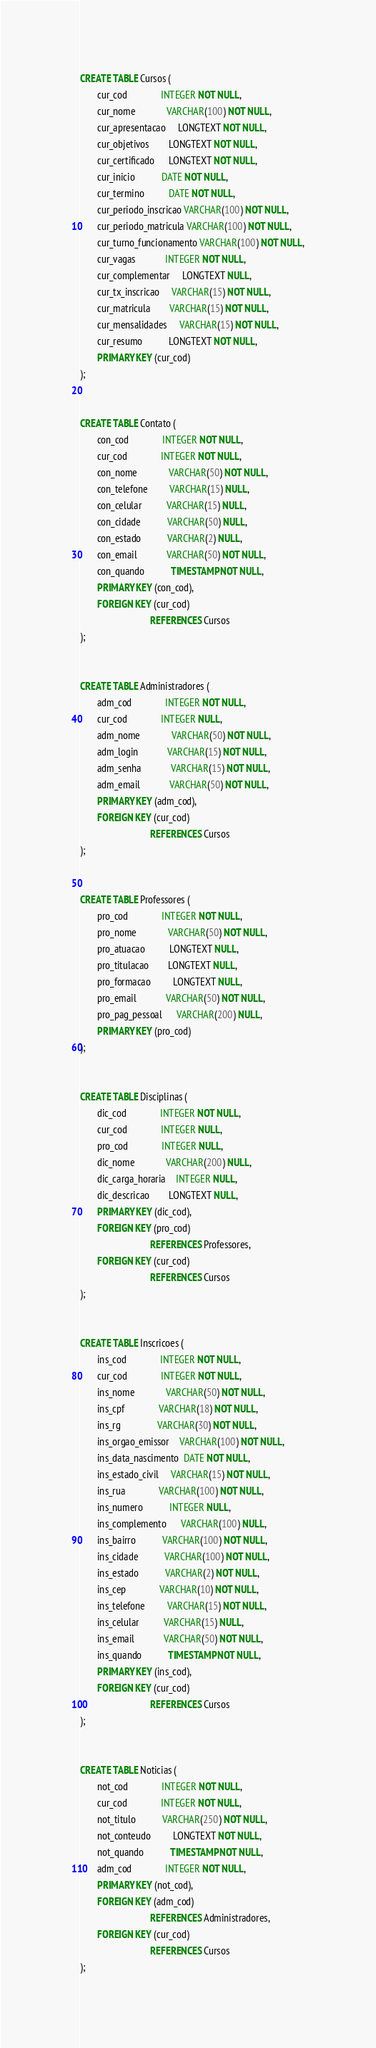<code> <loc_0><loc_0><loc_500><loc_500><_SQL_>
CREATE TABLE Cursos (
       cur_cod              INTEGER NOT NULL,
       cur_nome             VARCHAR(100) NOT NULL,
       cur_apresentacao     LONGTEXT NOT NULL,
       cur_objetivos        LONGTEXT NOT NULL,
       cur_certificado      LONGTEXT NOT NULL,
       cur_inicio           DATE NOT NULL,
       cur_termino          DATE NOT NULL,
       cur_periodo_inscricao VARCHAR(100) NOT NULL,
       cur_periodo_matricula VARCHAR(100) NOT NULL,
       cur_turno_funcionamento VARCHAR(100) NOT NULL,
       cur_vagas            INTEGER NOT NULL,
       cur_complementar     LONGTEXT NULL,
       cur_tx_inscricao     VARCHAR(15) NOT NULL,
       cur_matricula        VARCHAR(15) NOT NULL,
       cur_mensalidades     VARCHAR(15) NOT NULL,
       cur_resumo           LONGTEXT NOT NULL,
       PRIMARY KEY (cur_cod)
);


CREATE TABLE Contato (
       con_cod              INTEGER NOT NULL,
       cur_cod              INTEGER NOT NULL,
       con_nome             VARCHAR(50) NOT NULL,
       con_telefone         VARCHAR(15) NULL,
       con_celular          VARCHAR(15) NULL,
       con_cidade           VARCHAR(50) NULL,
       con_estado           VARCHAR(2) NULL,
       con_email            VARCHAR(50) NOT NULL,
       con_quando           TIMESTAMP NOT NULL,
       PRIMARY KEY (con_cod), 
       FOREIGN KEY (cur_cod)
                             REFERENCES Cursos
);


CREATE TABLE Administradores (
       adm_cod              INTEGER NOT NULL,
       cur_cod              INTEGER NULL,
       adm_nome             VARCHAR(50) NOT NULL,
       adm_login            VARCHAR(15) NOT NULL,
       adm_senha            VARCHAR(15) NOT NULL,
       adm_email            VARCHAR(50) NOT NULL,
       PRIMARY KEY (adm_cod), 
       FOREIGN KEY (cur_cod)
                             REFERENCES Cursos
);


CREATE TABLE Professores (
       pro_cod              INTEGER NOT NULL,
       pro_nome             VARCHAR(50) NOT NULL,
       pro_atuacao          LONGTEXT NULL,
       pro_titulacao        LONGTEXT NULL,
       pro_formacao         LONGTEXT NULL,
       pro_email            VARCHAR(50) NOT NULL,
       pro_pag_pessoal      VARCHAR(200) NULL,
       PRIMARY KEY (pro_cod)
);


CREATE TABLE Disciplinas (
       dic_cod              INTEGER NOT NULL,
       cur_cod              INTEGER NULL,
       pro_cod              INTEGER NULL,
       dic_nome             VARCHAR(200) NULL,
       dic_carga_horaria    INTEGER NULL,
       dic_descricao        LONGTEXT NULL,
       PRIMARY KEY (dic_cod), 
       FOREIGN KEY (pro_cod)
                             REFERENCES Professores, 
       FOREIGN KEY (cur_cod)
                             REFERENCES Cursos
);


CREATE TABLE Inscricoes (
       ins_cod              INTEGER NOT NULL,
       cur_cod              INTEGER NOT NULL,
       ins_nome             VARCHAR(50) NOT NULL,
       ins_cpf              VARCHAR(18) NOT NULL,
       ins_rg               VARCHAR(30) NOT NULL,
       ins_orgao_emissor    VARCHAR(100) NOT NULL,
       ins_data_nascimento  DATE NOT NULL,
       ins_estado_civil     VARCHAR(15) NOT NULL,
       ins_rua              VARCHAR(100) NOT NULL,
       ins_numero           INTEGER NULL,
       ins_complemento      VARCHAR(100) NULL,
       ins_bairro           VARCHAR(100) NOT NULL,
       ins_cidade           VARCHAR(100) NOT NULL,
       ins_estado           VARCHAR(2) NOT NULL,
       ins_cep              VARCHAR(10) NOT NULL,
       ins_telefone         VARCHAR(15) NOT NULL,
       ins_celular          VARCHAR(15) NULL,
       ins_email            VARCHAR(50) NOT NULL,
       ins_quando           TIMESTAMP NOT NULL,
       PRIMARY KEY (ins_cod), 
       FOREIGN KEY (cur_cod)
                             REFERENCES Cursos
);


CREATE TABLE Noticias (
       not_cod              INTEGER NOT NULL,
       cur_cod              INTEGER NOT NULL,
       not_titulo           VARCHAR(250) NOT NULL,
       not_conteudo         LONGTEXT NOT NULL,
       not_quando           TIMESTAMP NOT NULL,
       adm_cod              INTEGER NOT NULL,
       PRIMARY KEY (not_cod), 
       FOREIGN KEY (adm_cod)
                             REFERENCES Administradores, 
       FOREIGN KEY (cur_cod)
                             REFERENCES Cursos
);



</code> 